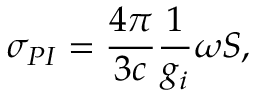<formula> <loc_0><loc_0><loc_500><loc_500>\sigma _ { P I } = { \frac { 4 \pi } { 3 c } } { \frac { 1 } { g _ { i } } } \omega S ,</formula> 